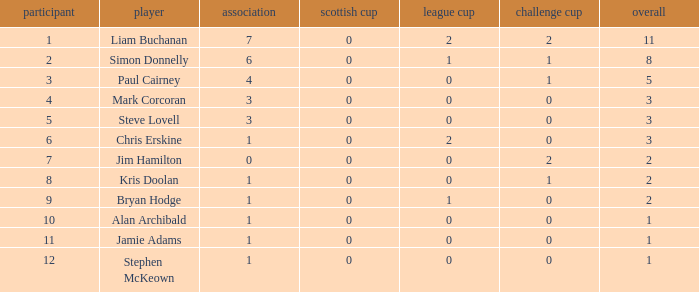Could you parse the entire table as a dict? {'header': ['participant', 'player', 'association', 'scottish cup', 'league cup', 'challenge cup', 'overall'], 'rows': [['1', 'Liam Buchanan', '7', '0', '2', '2', '11'], ['2', 'Simon Donnelly', '6', '0', '1', '1', '8'], ['3', 'Paul Cairney', '4', '0', '0', '1', '5'], ['4', 'Mark Corcoran', '3', '0', '0', '0', '3'], ['5', 'Steve Lovell', '3', '0', '0', '0', '3'], ['6', 'Chris Erskine', '1', '0', '2', '0', '3'], ['7', 'Jim Hamilton', '0', '0', '0', '2', '2'], ['8', 'Kris Doolan', '1', '0', '0', '1', '2'], ['9', 'Bryan Hodge', '1', '0', '1', '0', '2'], ['10', 'Alan Archibald', '1', '0', '0', '0', '1'], ['11', 'Jamie Adams', '1', '0', '0', '0', '1'], ['12', 'Stephen McKeown', '1', '0', '0', '0', '1']]} How many points did player 7 score in the challenge cup? 1.0. 